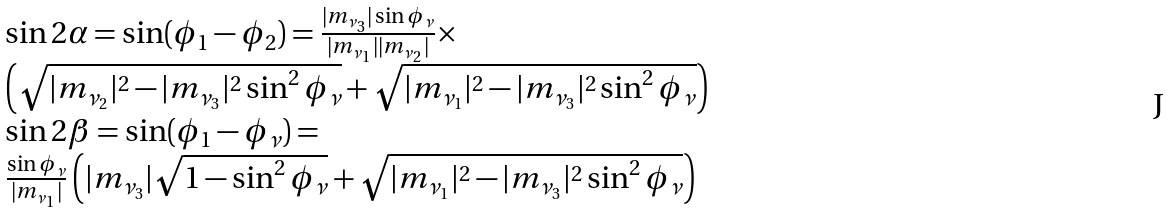Convert formula to latex. <formula><loc_0><loc_0><loc_500><loc_500>\begin{array} { l } \sin 2 \alpha = \sin ( \phi _ { 1 } - \phi _ { 2 } ) = \frac { | m _ { \nu _ { 3 } } | \sin \phi _ { \nu } } { | m _ { \nu _ { 1 } } | | m _ { \nu _ { 2 } } | } \times \\ \left ( \sqrt { | m _ { \nu _ { 2 } } | ^ { 2 } - | m _ { \nu _ { 3 } } | ^ { 2 } \sin ^ { 2 } \phi _ { \nu } } + \sqrt { | m _ { \nu _ { 1 } } | ^ { 2 } - | m _ { \nu _ { 3 } } | ^ { 2 } \sin ^ { 2 } \phi _ { \nu } } \right ) \\ \sin 2 \beta = \sin ( \phi _ { 1 } - \phi _ { \nu } ) = \\ \frac { \sin \phi _ { \nu } } { | m _ { \nu _ { 1 } } | } \left ( | m _ { \nu _ { 3 } } | \sqrt { 1 - \sin ^ { 2 } \phi _ { \nu } } + \sqrt { | m _ { \nu _ { 1 } } | ^ { 2 } - | m _ { \nu _ { 3 } } | ^ { 2 } \sin ^ { 2 } \phi _ { \nu } } \right ) \end{array}</formula> 